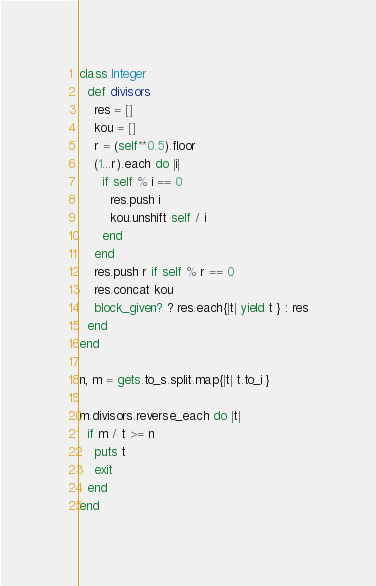Convert code to text. <code><loc_0><loc_0><loc_500><loc_500><_Ruby_>class Integer
  def divisors
    res = []
    kou = []
    r = (self**0.5).floor
    (1...r).each do |i|
      if self % i == 0
        res.push i
        kou.unshift self / i
      end
    end
    res.push r if self % r == 0
    res.concat kou
    block_given? ? res.each{|t| yield t } : res
  end
end

n, m = gets.to_s.split.map{|t| t.to_i }
 
m.divisors.reverse_each do |t|
  if m / t >= n
    puts t
    exit
  end
end</code> 